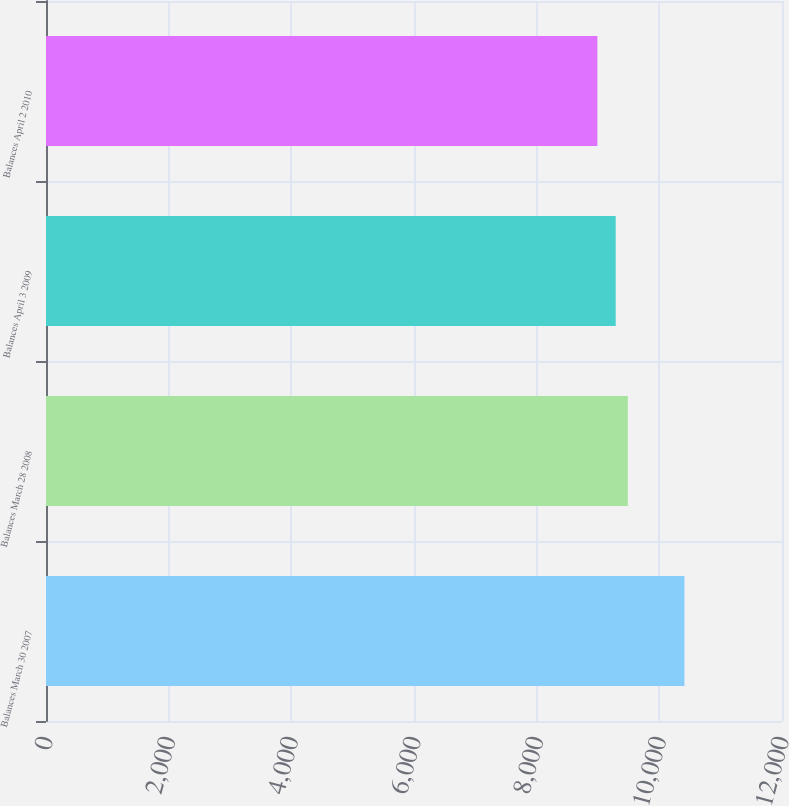<chart> <loc_0><loc_0><loc_500><loc_500><bar_chart><fcel>Balances March 30 2007<fcel>Balances March 28 2008<fcel>Balances April 3 2009<fcel>Balances April 2 2010<nl><fcel>10409<fcel>9487<fcel>9289<fcel>8990<nl></chart> 